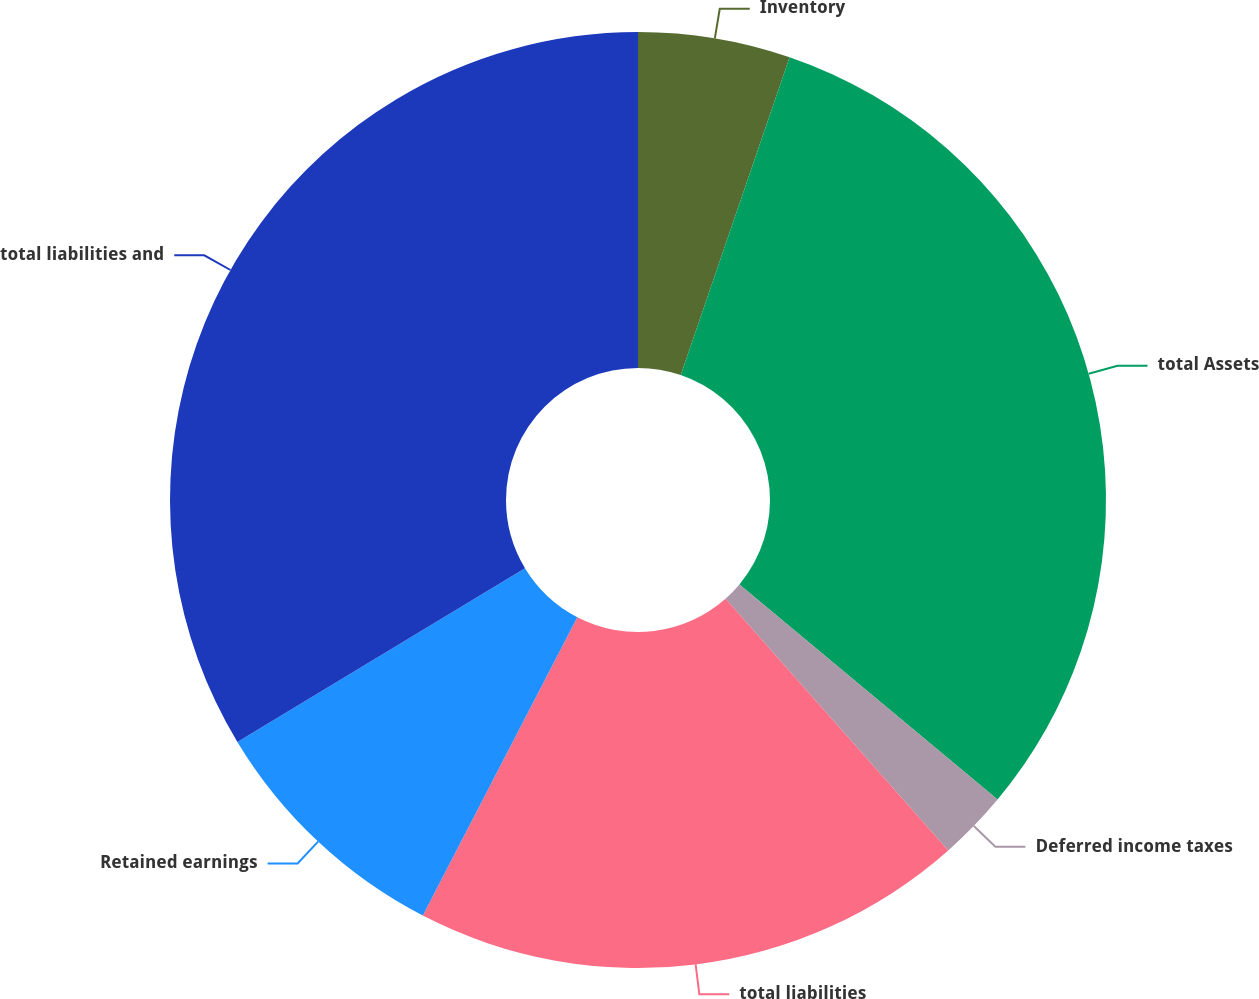Convert chart to OTSL. <chart><loc_0><loc_0><loc_500><loc_500><pie_chart><fcel>Inventory<fcel>total Assets<fcel>Deferred income taxes<fcel>total liabilities<fcel>Retained earnings<fcel>total liabilities and<nl><fcel>5.25%<fcel>30.81%<fcel>2.41%<fcel>19.14%<fcel>8.75%<fcel>33.65%<nl></chart> 